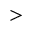Convert formula to latex. <formula><loc_0><loc_0><loc_500><loc_500>></formula> 